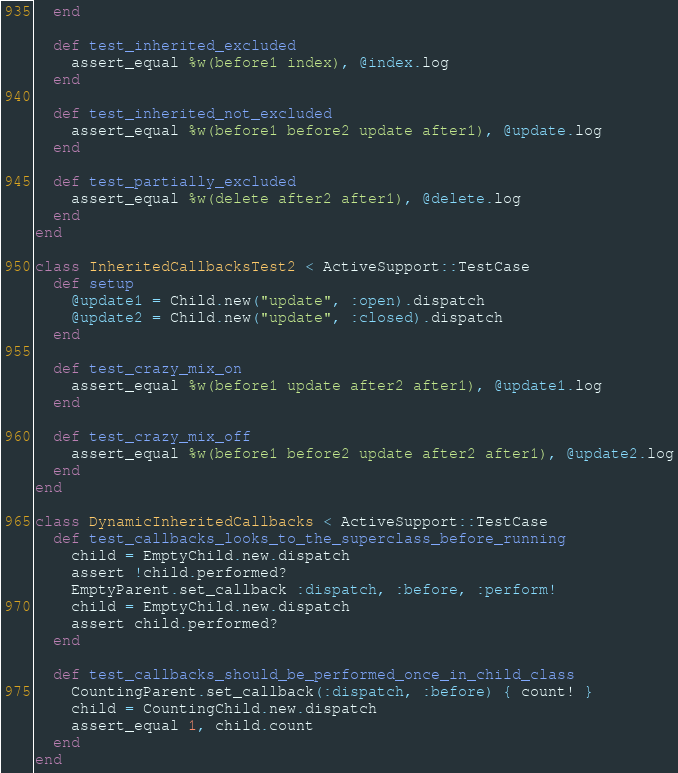Convert code to text. <code><loc_0><loc_0><loc_500><loc_500><_Ruby_>  end

  def test_inherited_excluded
    assert_equal %w(before1 index), @index.log
  end

  def test_inherited_not_excluded
    assert_equal %w(before1 before2 update after1), @update.log
  end

  def test_partially_excluded
    assert_equal %w(delete after2 after1), @delete.log
  end
end

class InheritedCallbacksTest2 < ActiveSupport::TestCase
  def setup
    @update1 = Child.new("update", :open).dispatch
    @update2 = Child.new("update", :closed).dispatch
  end

  def test_crazy_mix_on
    assert_equal %w(before1 update after2 after1), @update1.log
  end

  def test_crazy_mix_off
    assert_equal %w(before1 before2 update after2 after1), @update2.log
  end
end

class DynamicInheritedCallbacks < ActiveSupport::TestCase
  def test_callbacks_looks_to_the_superclass_before_running
    child = EmptyChild.new.dispatch
    assert !child.performed?
    EmptyParent.set_callback :dispatch, :before, :perform!
    child = EmptyChild.new.dispatch
    assert child.performed?
  end

  def test_callbacks_should_be_performed_once_in_child_class
    CountingParent.set_callback(:dispatch, :before) { count! }
    child = CountingChild.new.dispatch
    assert_equal 1, child.count
  end
end
</code> 